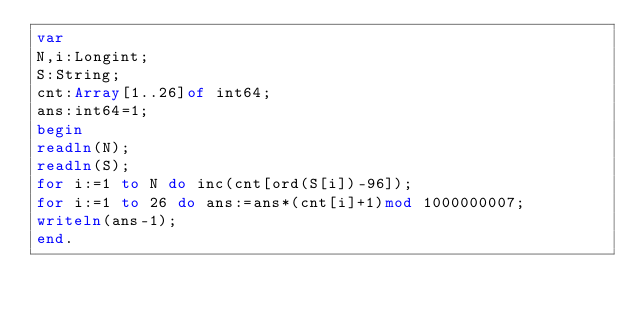<code> <loc_0><loc_0><loc_500><loc_500><_Pascal_>var
N,i:Longint;
S:String;
cnt:Array[1..26]of int64;
ans:int64=1;
begin
readln(N);
readln(S);
for i:=1 to N do inc(cnt[ord(S[i])-96]);
for i:=1 to 26 do ans:=ans*(cnt[i]+1)mod 1000000007;
writeln(ans-1);
end.</code> 